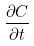Convert formula to latex. <formula><loc_0><loc_0><loc_500><loc_500>\frac { \partial C } { \partial t }</formula> 